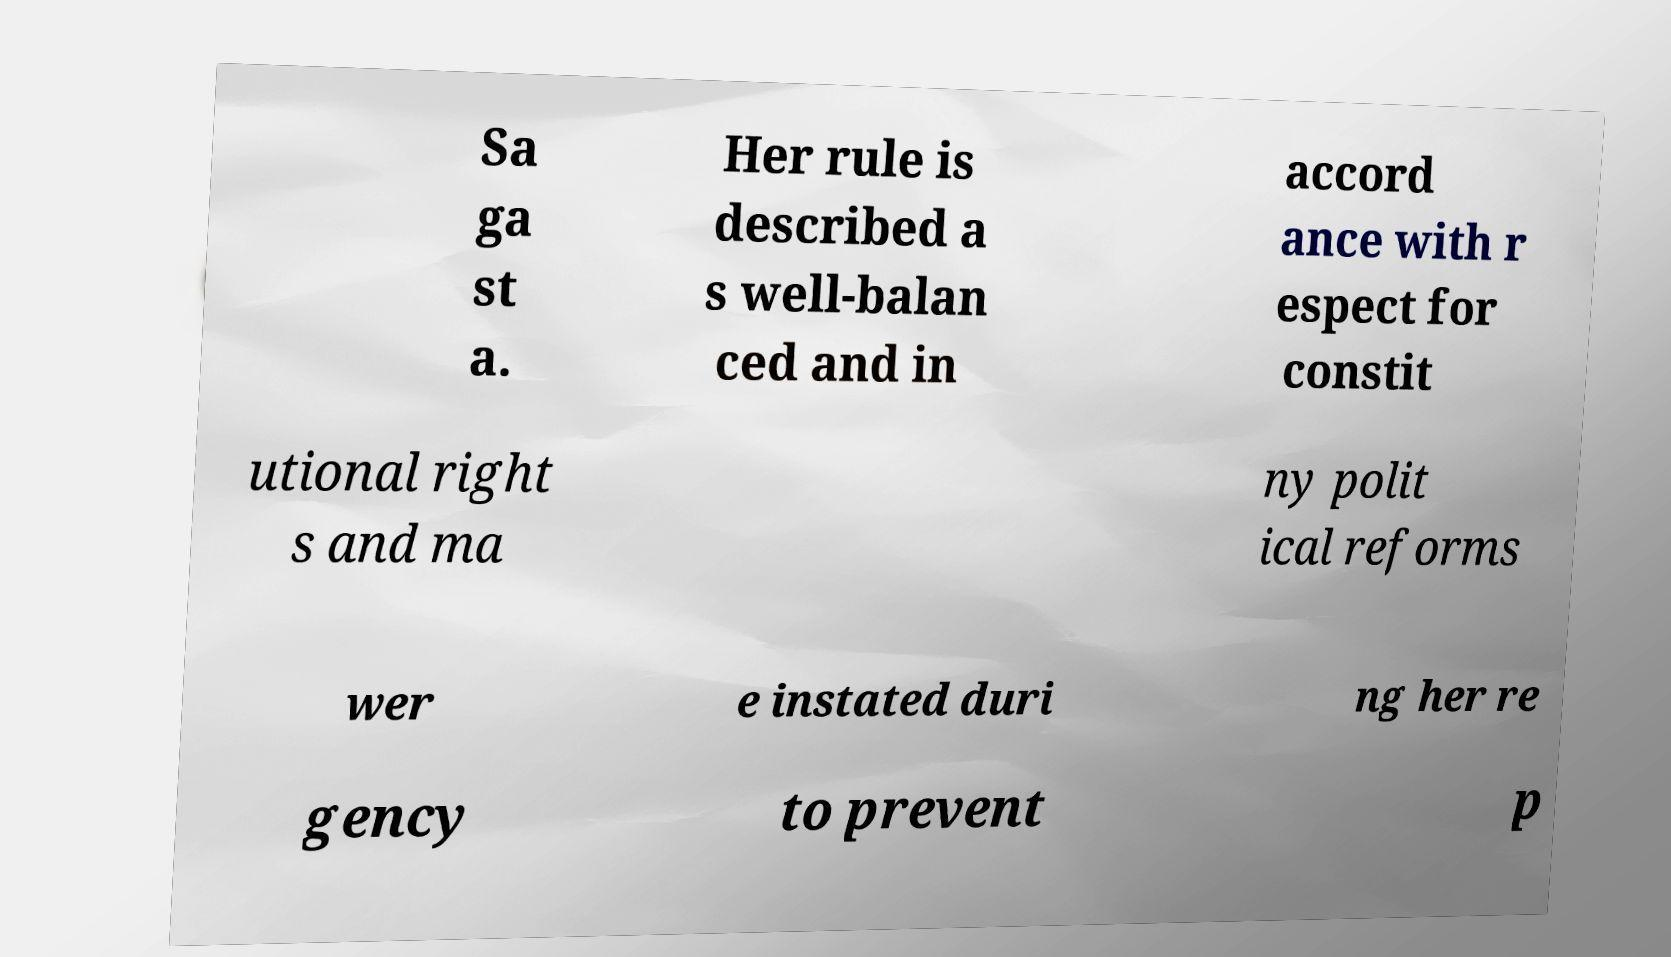For documentation purposes, I need the text within this image transcribed. Could you provide that? Sa ga st a. Her rule is described a s well-balan ced and in accord ance with r espect for constit utional right s and ma ny polit ical reforms wer e instated duri ng her re gency to prevent p 